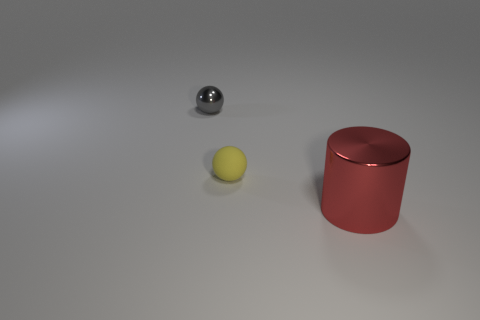What is the color of the object that is both to the right of the gray ball and left of the big object?
Ensure brevity in your answer.  Yellow. There is a object that is both behind the cylinder and in front of the tiny shiny sphere; how big is it?
Offer a terse response. Small. What number of other objects are the same color as the large shiny cylinder?
Your response must be concise. 0. What size is the object in front of the small yellow rubber thing that is right of the thing left of the yellow matte thing?
Your response must be concise. Large. There is a small gray ball; are there any objects on the left side of it?
Provide a short and direct response. No. There is a gray shiny thing; does it have the same size as the metal object that is in front of the tiny yellow thing?
Your answer should be very brief. No. How many other things are the same material as the big red cylinder?
Provide a succinct answer. 1. The object that is both behind the large metal cylinder and to the right of the tiny gray object has what shape?
Make the answer very short. Sphere. There is a object to the left of the yellow rubber sphere; does it have the same size as the object to the right of the yellow matte thing?
Provide a succinct answer. No. There is another object that is made of the same material as the red object; what shape is it?
Offer a very short reply. Sphere. 